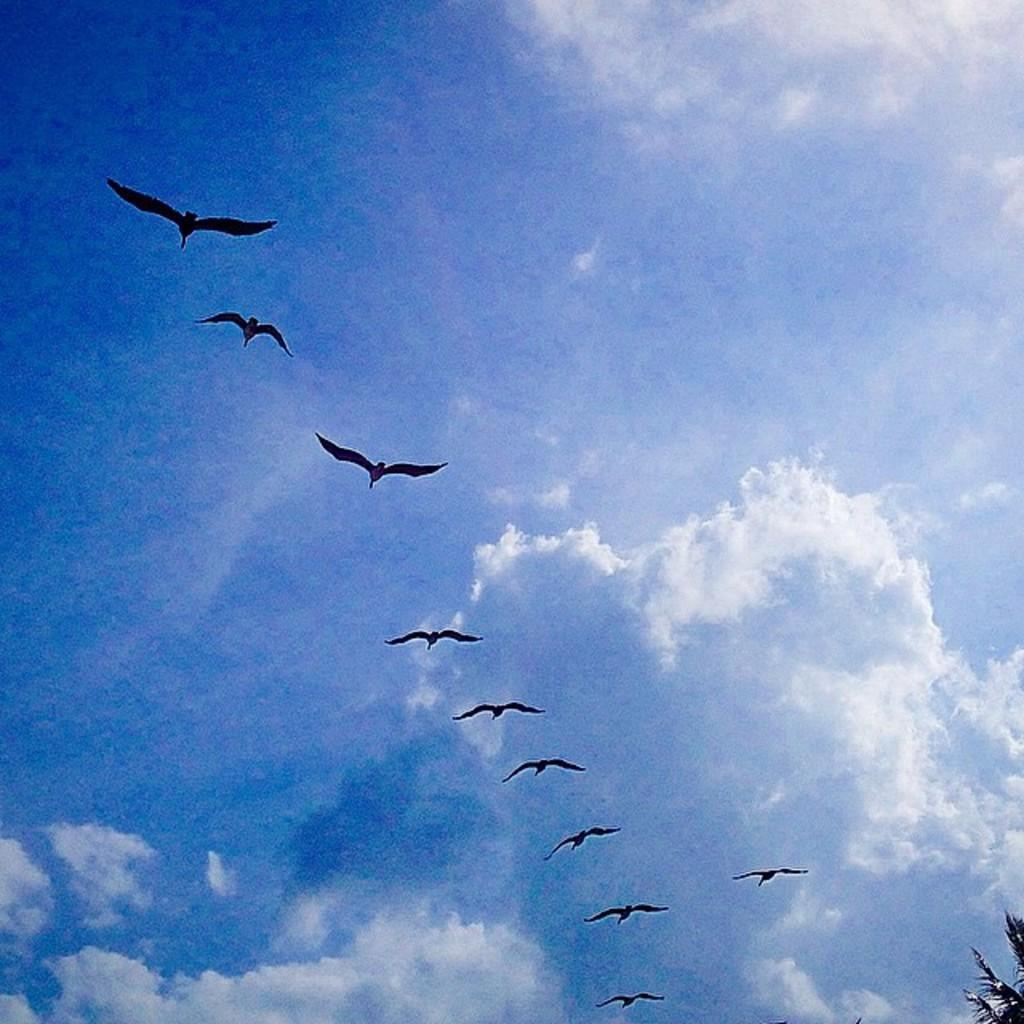What type of animals can be seen in the image? Birds can be seen in the image. What are the birds doing in the image? The birds are flying in the sky. What type of field can be seen in the image? There is no field present in the image; it features birds flying in the sky. What is in the pocket of the bird in the image? There is no bird with a pocket present in the image. 